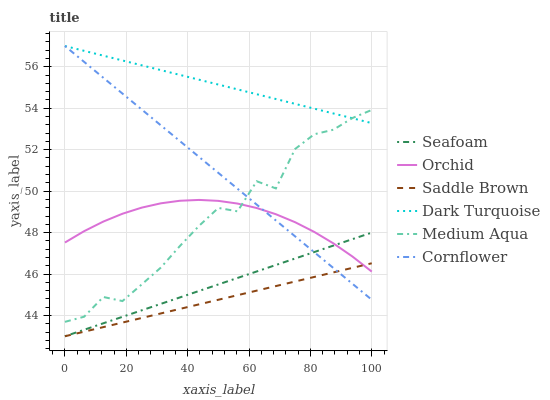Does Saddle Brown have the minimum area under the curve?
Answer yes or no. Yes. Does Dark Turquoise have the maximum area under the curve?
Answer yes or no. Yes. Does Seafoam have the minimum area under the curve?
Answer yes or no. No. Does Seafoam have the maximum area under the curve?
Answer yes or no. No. Is Cornflower the smoothest?
Answer yes or no. Yes. Is Medium Aqua the roughest?
Answer yes or no. Yes. Is Dark Turquoise the smoothest?
Answer yes or no. No. Is Dark Turquoise the roughest?
Answer yes or no. No. Does Seafoam have the lowest value?
Answer yes or no. Yes. Does Dark Turquoise have the lowest value?
Answer yes or no. No. Does Dark Turquoise have the highest value?
Answer yes or no. Yes. Does Seafoam have the highest value?
Answer yes or no. No. Is Orchid less than Dark Turquoise?
Answer yes or no. Yes. Is Dark Turquoise greater than Orchid?
Answer yes or no. Yes. Does Seafoam intersect Saddle Brown?
Answer yes or no. Yes. Is Seafoam less than Saddle Brown?
Answer yes or no. No. Is Seafoam greater than Saddle Brown?
Answer yes or no. No. Does Orchid intersect Dark Turquoise?
Answer yes or no. No. 